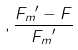Convert formula to latex. <formula><loc_0><loc_0><loc_500><loc_500>, \frac { { F _ { m } } ^ { \prime } - F } { { F _ { m } } ^ { \prime } }</formula> 